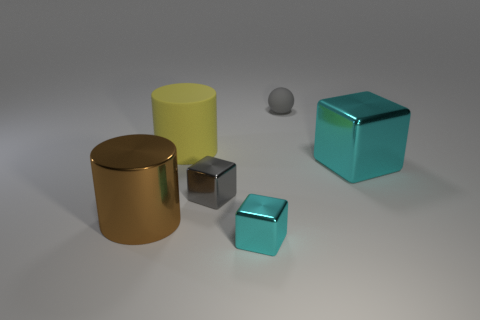Add 2 gray shiny things. How many objects exist? 8 Subtract all spheres. How many objects are left? 5 Add 6 large cyan things. How many large cyan things are left? 7 Add 6 big cyan spheres. How many big cyan spheres exist? 6 Subtract 1 cyan cubes. How many objects are left? 5 Subtract all large rubber cylinders. Subtract all cylinders. How many objects are left? 3 